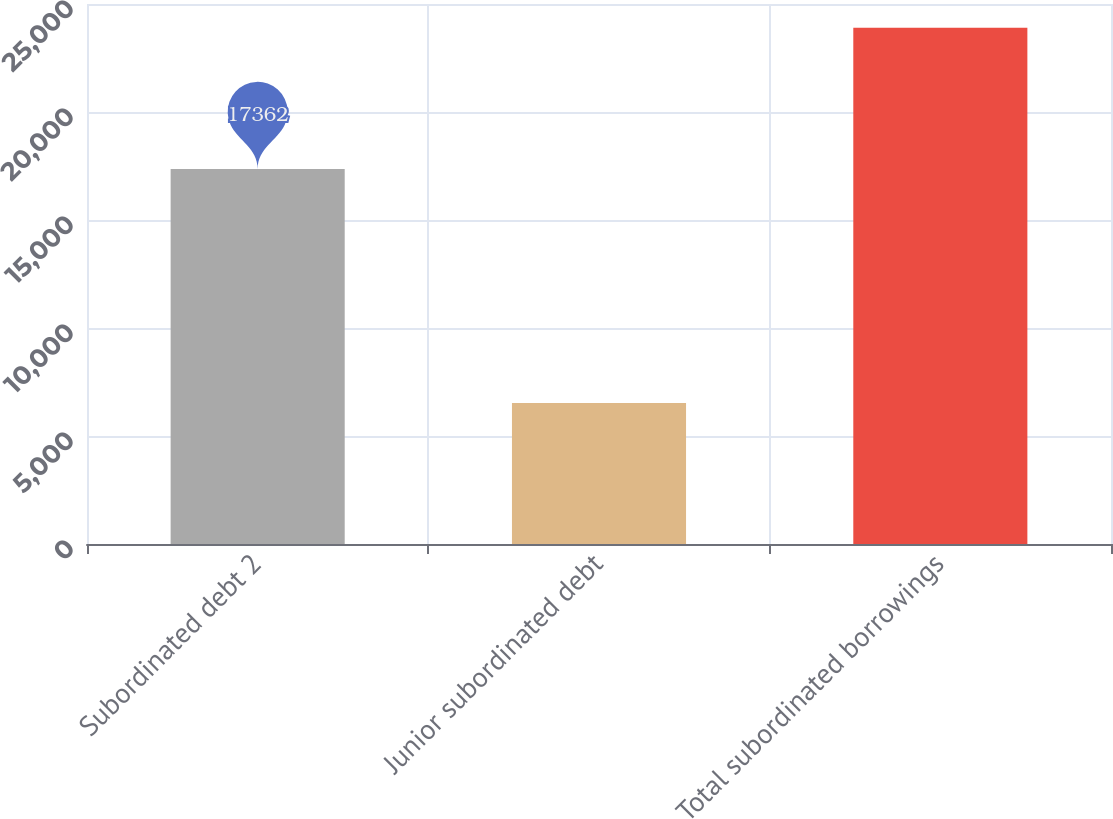Convert chart to OTSL. <chart><loc_0><loc_0><loc_500><loc_500><bar_chart><fcel>Subordinated debt 2<fcel>Junior subordinated debt<fcel>Total subordinated borrowings<nl><fcel>17362<fcel>6533<fcel>23895<nl></chart> 